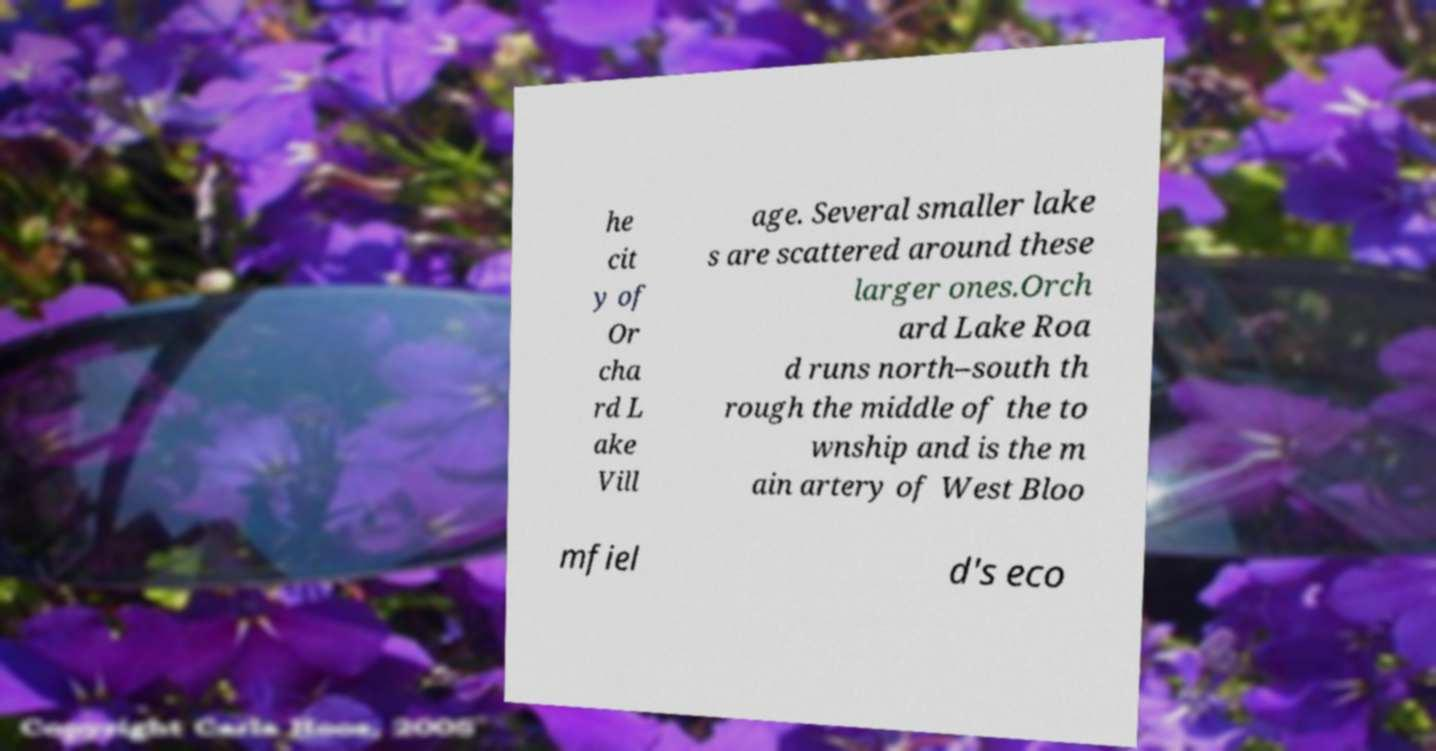For documentation purposes, I need the text within this image transcribed. Could you provide that? he cit y of Or cha rd L ake Vill age. Several smaller lake s are scattered around these larger ones.Orch ard Lake Roa d runs north–south th rough the middle of the to wnship and is the m ain artery of West Bloo mfiel d's eco 